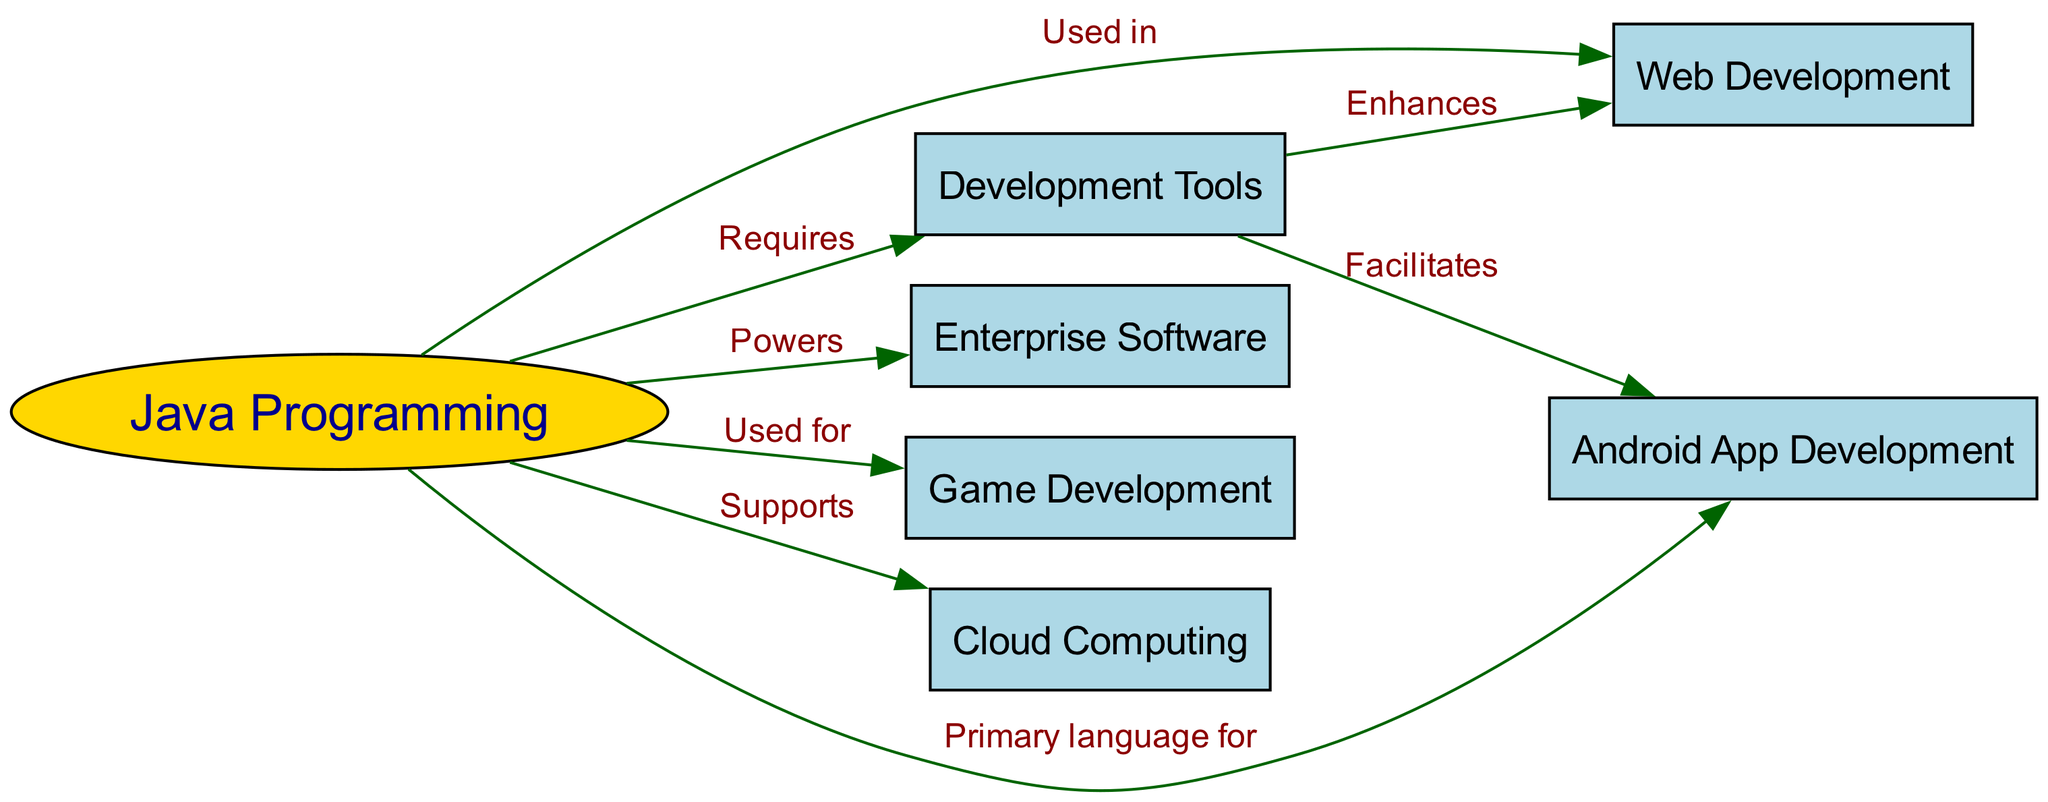What is the primary language for Android App Development? The diagram indicates a direct connection from the "Java Programming" node to the "Android App Development" node with the label "Primary language for." This suggests that the answer to this question is related to Java's role in Android development.
Answer: Java How many nodes are in the diagram? By counting the nodes listed in the "nodes" section of the data, we observe that there are a total of six nodes representing different areas related to Java, including Java Programming, Web Development, Android App Development, Enterprise Software, Game Development, Cloud Computing, and Development Tools. Thus, the total count is six.
Answer: 6 What does Java support according to the diagram? In the diagram, the edge connecting "Java Programming" to "Cloud Computing" has the label "Supports," indicating that Java plays a supportive role in the domain of cloud computing.
Answer: Cloud Computing Which application area is enhanced by Development Tools? The diagram connects "Development Tools" to "Web Development" with the label "Enhances," specifically highlighting that development tools improve or add to the web development process.
Answer: Web Development List two areas where Java is used. Based on the connections in the diagram, Java is indicated as being used for "Web Development" and "Game Development," as shown by the edges labeled "Used in" and "Used for," respectively. To answer the question, we can simply list both.
Answer: Web Development, Game Development Which application area does Enterprise Software power? The diagram shows an edge from the "Java Programming" node to the "Enterprise Software" node labeled "Powers." This indicates that Java is instrumental in the functioning of enterprise software applications.
Answer: Enterprise Software What relationship does Java have with Android App Development? The diagram illustrates that Java is the primary programming language used for Android app development through the edge from "Java Programming" to "Android App Development" labeled "Primary language for." Therefore, the relationship is one of primary usage.
Answer: Primary language for What enhances Android App Development? According to the diagram, "Development Tools" is connected to "Android App Development" with the label "Facilitates," suggesting that development tools play a key role in aiding or facilitating the process of Android app development.
Answer: Development Tools 